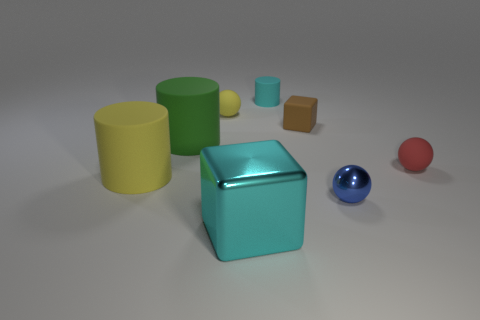Add 1 tiny red metal balls. How many objects exist? 9 Subtract all cubes. How many objects are left? 6 Subtract 1 red spheres. How many objects are left? 7 Subtract all red rubber things. Subtract all tiny red matte blocks. How many objects are left? 7 Add 4 metal blocks. How many metal blocks are left? 5 Add 8 large rubber cylinders. How many large rubber cylinders exist? 10 